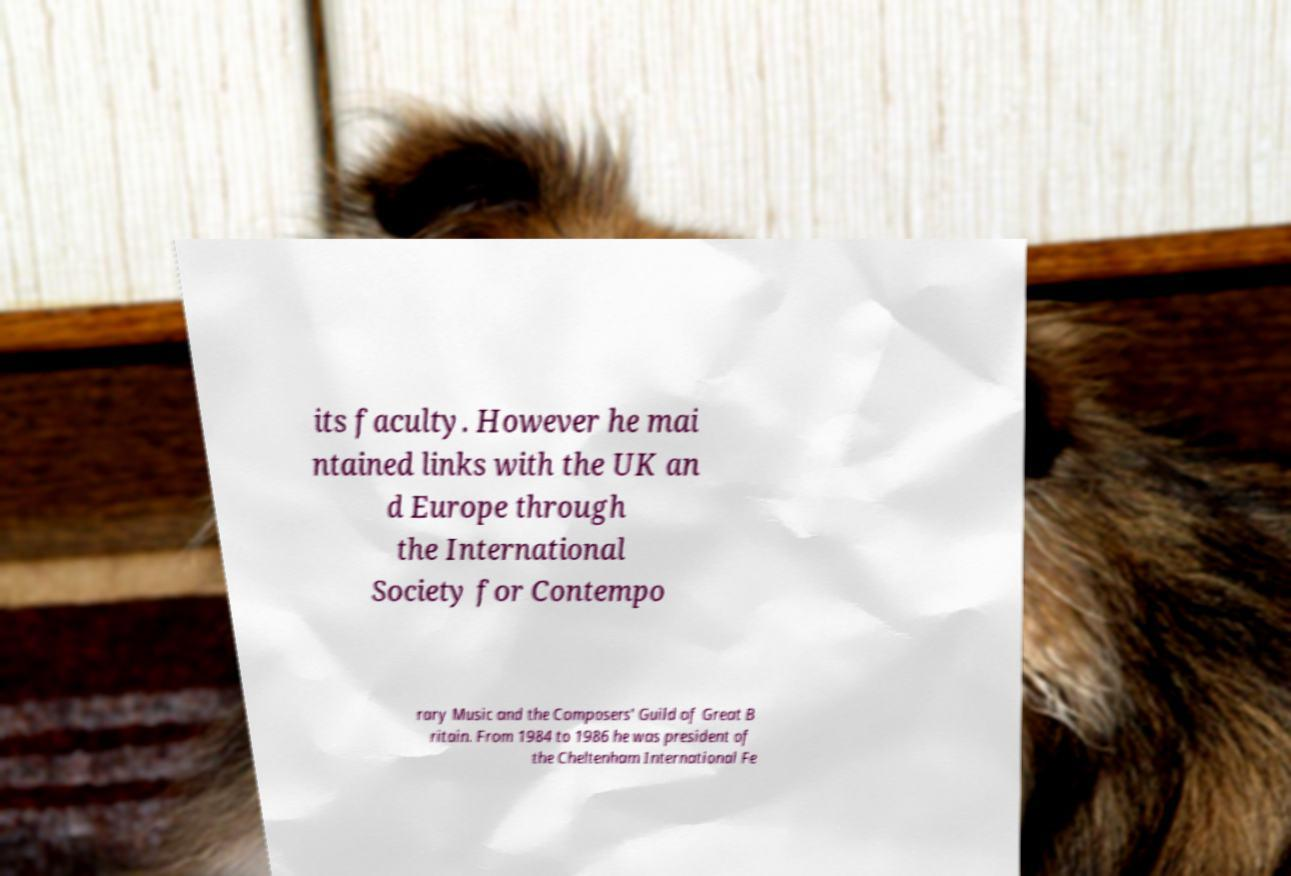I need the written content from this picture converted into text. Can you do that? its faculty. However he mai ntained links with the UK an d Europe through the International Society for Contempo rary Music and the Composers' Guild of Great B ritain. From 1984 to 1986 he was president of the Cheltenham International Fe 